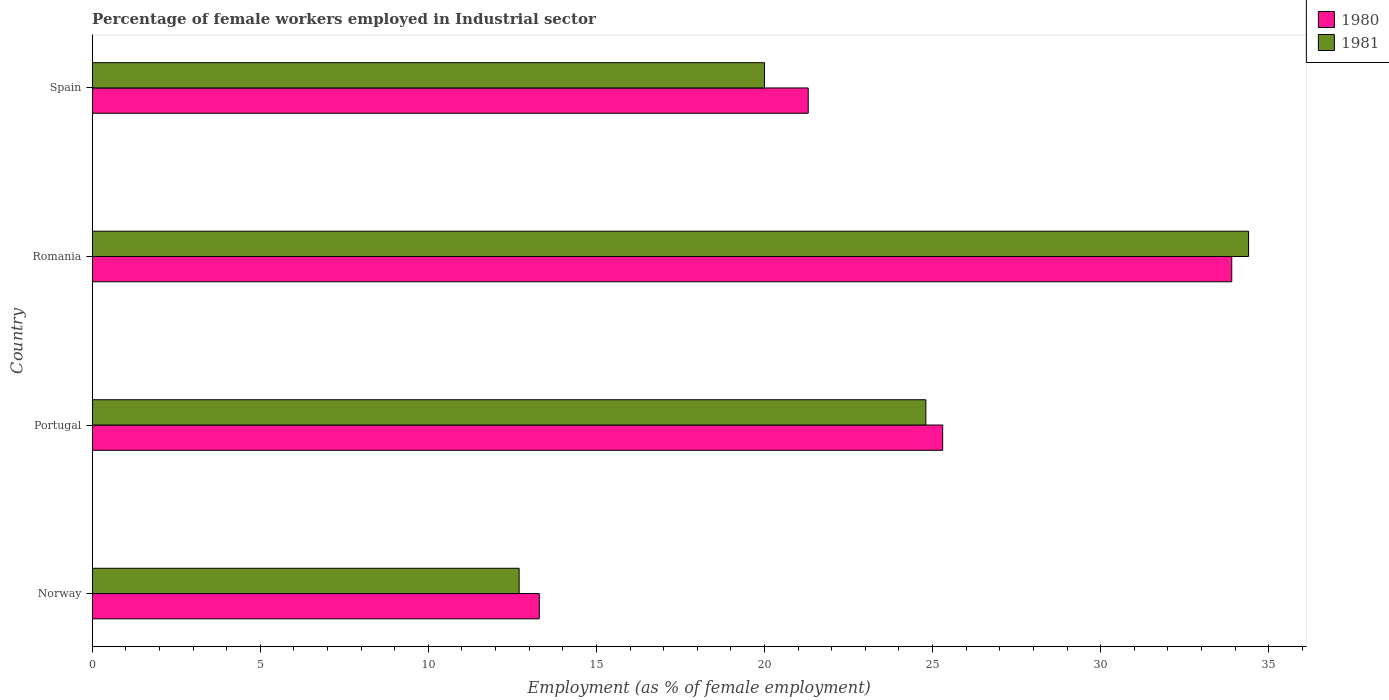Are the number of bars on each tick of the Y-axis equal?
Give a very brief answer. Yes. How many bars are there on the 4th tick from the top?
Make the answer very short. 2. How many bars are there on the 1st tick from the bottom?
Make the answer very short. 2. What is the label of the 2nd group of bars from the top?
Provide a succinct answer. Romania. What is the percentage of females employed in Industrial sector in 1980 in Norway?
Provide a short and direct response. 13.3. Across all countries, what is the maximum percentage of females employed in Industrial sector in 1980?
Your answer should be very brief. 33.9. Across all countries, what is the minimum percentage of females employed in Industrial sector in 1980?
Your answer should be very brief. 13.3. In which country was the percentage of females employed in Industrial sector in 1981 maximum?
Offer a terse response. Romania. In which country was the percentage of females employed in Industrial sector in 1981 minimum?
Ensure brevity in your answer.  Norway. What is the total percentage of females employed in Industrial sector in 1980 in the graph?
Offer a very short reply. 93.8. What is the difference between the percentage of females employed in Industrial sector in 1981 in Romania and that in Spain?
Offer a very short reply. 14.4. What is the difference between the percentage of females employed in Industrial sector in 1981 in Spain and the percentage of females employed in Industrial sector in 1980 in Romania?
Provide a short and direct response. -13.9. What is the average percentage of females employed in Industrial sector in 1981 per country?
Give a very brief answer. 22.98. What is the difference between the percentage of females employed in Industrial sector in 1980 and percentage of females employed in Industrial sector in 1981 in Norway?
Provide a short and direct response. 0.6. In how many countries, is the percentage of females employed in Industrial sector in 1981 greater than 27 %?
Keep it short and to the point. 1. What is the ratio of the percentage of females employed in Industrial sector in 1980 in Portugal to that in Romania?
Make the answer very short. 0.75. Is the percentage of females employed in Industrial sector in 1980 in Norway less than that in Spain?
Give a very brief answer. Yes. What is the difference between the highest and the second highest percentage of females employed in Industrial sector in 1980?
Provide a short and direct response. 8.6. What is the difference between the highest and the lowest percentage of females employed in Industrial sector in 1981?
Your response must be concise. 21.7. Is the sum of the percentage of females employed in Industrial sector in 1980 in Norway and Portugal greater than the maximum percentage of females employed in Industrial sector in 1981 across all countries?
Provide a short and direct response. Yes. What does the 1st bar from the bottom in Romania represents?
Give a very brief answer. 1980. How many countries are there in the graph?
Your answer should be compact. 4. What is the difference between two consecutive major ticks on the X-axis?
Your response must be concise. 5. Does the graph contain any zero values?
Ensure brevity in your answer.  No. Does the graph contain grids?
Ensure brevity in your answer.  No. What is the title of the graph?
Offer a terse response. Percentage of female workers employed in Industrial sector. What is the label or title of the X-axis?
Ensure brevity in your answer.  Employment (as % of female employment). What is the Employment (as % of female employment) in 1980 in Norway?
Your answer should be very brief. 13.3. What is the Employment (as % of female employment) in 1981 in Norway?
Keep it short and to the point. 12.7. What is the Employment (as % of female employment) in 1980 in Portugal?
Offer a terse response. 25.3. What is the Employment (as % of female employment) of 1981 in Portugal?
Provide a succinct answer. 24.8. What is the Employment (as % of female employment) in 1980 in Romania?
Your response must be concise. 33.9. What is the Employment (as % of female employment) in 1981 in Romania?
Offer a terse response. 34.4. What is the Employment (as % of female employment) of 1980 in Spain?
Offer a very short reply. 21.3. Across all countries, what is the maximum Employment (as % of female employment) in 1980?
Your response must be concise. 33.9. Across all countries, what is the maximum Employment (as % of female employment) of 1981?
Provide a short and direct response. 34.4. Across all countries, what is the minimum Employment (as % of female employment) in 1980?
Provide a succinct answer. 13.3. Across all countries, what is the minimum Employment (as % of female employment) in 1981?
Provide a succinct answer. 12.7. What is the total Employment (as % of female employment) in 1980 in the graph?
Your answer should be very brief. 93.8. What is the total Employment (as % of female employment) in 1981 in the graph?
Your answer should be compact. 91.9. What is the difference between the Employment (as % of female employment) of 1981 in Norway and that in Portugal?
Keep it short and to the point. -12.1. What is the difference between the Employment (as % of female employment) in 1980 in Norway and that in Romania?
Ensure brevity in your answer.  -20.6. What is the difference between the Employment (as % of female employment) in 1981 in Norway and that in Romania?
Provide a short and direct response. -21.7. What is the difference between the Employment (as % of female employment) of 1981 in Norway and that in Spain?
Provide a succinct answer. -7.3. What is the difference between the Employment (as % of female employment) in 1980 in Portugal and that in Romania?
Ensure brevity in your answer.  -8.6. What is the difference between the Employment (as % of female employment) of 1981 in Portugal and that in Romania?
Your answer should be very brief. -9.6. What is the difference between the Employment (as % of female employment) of 1980 in Portugal and that in Spain?
Offer a terse response. 4. What is the difference between the Employment (as % of female employment) in 1981 in Portugal and that in Spain?
Your answer should be very brief. 4.8. What is the difference between the Employment (as % of female employment) of 1980 in Romania and that in Spain?
Make the answer very short. 12.6. What is the difference between the Employment (as % of female employment) in 1980 in Norway and the Employment (as % of female employment) in 1981 in Portugal?
Keep it short and to the point. -11.5. What is the difference between the Employment (as % of female employment) in 1980 in Norway and the Employment (as % of female employment) in 1981 in Romania?
Make the answer very short. -21.1. What is the difference between the Employment (as % of female employment) of 1980 in Norway and the Employment (as % of female employment) of 1981 in Spain?
Your answer should be compact. -6.7. What is the difference between the Employment (as % of female employment) of 1980 in Portugal and the Employment (as % of female employment) of 1981 in Romania?
Offer a very short reply. -9.1. What is the difference between the Employment (as % of female employment) in 1980 in Portugal and the Employment (as % of female employment) in 1981 in Spain?
Keep it short and to the point. 5.3. What is the difference between the Employment (as % of female employment) in 1980 in Romania and the Employment (as % of female employment) in 1981 in Spain?
Offer a terse response. 13.9. What is the average Employment (as % of female employment) in 1980 per country?
Provide a short and direct response. 23.45. What is the average Employment (as % of female employment) in 1981 per country?
Make the answer very short. 22.98. What is the difference between the Employment (as % of female employment) in 1980 and Employment (as % of female employment) in 1981 in Norway?
Offer a very short reply. 0.6. What is the difference between the Employment (as % of female employment) of 1980 and Employment (as % of female employment) of 1981 in Romania?
Provide a short and direct response. -0.5. What is the difference between the Employment (as % of female employment) of 1980 and Employment (as % of female employment) of 1981 in Spain?
Give a very brief answer. 1.3. What is the ratio of the Employment (as % of female employment) in 1980 in Norway to that in Portugal?
Give a very brief answer. 0.53. What is the ratio of the Employment (as % of female employment) of 1981 in Norway to that in Portugal?
Ensure brevity in your answer.  0.51. What is the ratio of the Employment (as % of female employment) in 1980 in Norway to that in Romania?
Make the answer very short. 0.39. What is the ratio of the Employment (as % of female employment) of 1981 in Norway to that in Romania?
Provide a short and direct response. 0.37. What is the ratio of the Employment (as % of female employment) of 1980 in Norway to that in Spain?
Give a very brief answer. 0.62. What is the ratio of the Employment (as % of female employment) in 1981 in Norway to that in Spain?
Make the answer very short. 0.64. What is the ratio of the Employment (as % of female employment) of 1980 in Portugal to that in Romania?
Keep it short and to the point. 0.75. What is the ratio of the Employment (as % of female employment) of 1981 in Portugal to that in Romania?
Your answer should be very brief. 0.72. What is the ratio of the Employment (as % of female employment) in 1980 in Portugal to that in Spain?
Your answer should be compact. 1.19. What is the ratio of the Employment (as % of female employment) in 1981 in Portugal to that in Spain?
Provide a short and direct response. 1.24. What is the ratio of the Employment (as % of female employment) of 1980 in Romania to that in Spain?
Your response must be concise. 1.59. What is the ratio of the Employment (as % of female employment) in 1981 in Romania to that in Spain?
Keep it short and to the point. 1.72. What is the difference between the highest and the lowest Employment (as % of female employment) in 1980?
Offer a very short reply. 20.6. What is the difference between the highest and the lowest Employment (as % of female employment) of 1981?
Offer a terse response. 21.7. 